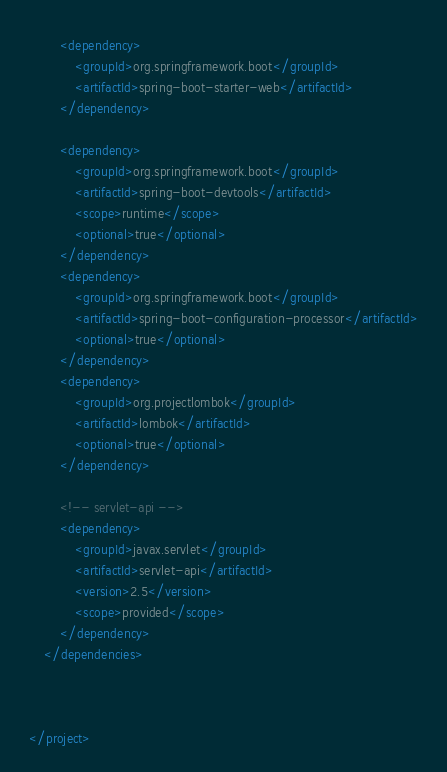<code> <loc_0><loc_0><loc_500><loc_500><_XML_>

		<dependency>
			<groupId>org.springframework.boot</groupId>
			<artifactId>spring-boot-starter-web</artifactId>
		</dependency>

		<dependency>
			<groupId>org.springframework.boot</groupId>
			<artifactId>spring-boot-devtools</artifactId>
			<scope>runtime</scope>
			<optional>true</optional>
		</dependency>
		<dependency>
			<groupId>org.springframework.boot</groupId>
			<artifactId>spring-boot-configuration-processor</artifactId>
			<optional>true</optional>
		</dependency>
		<dependency>
			<groupId>org.projectlombok</groupId>
			<artifactId>lombok</artifactId>
			<optional>true</optional>
		</dependency>

		<!-- servlet-api -->
		<dependency>
			<groupId>javax.servlet</groupId>
			<artifactId>servlet-api</artifactId>
			<version>2.5</version>
			<scope>provided</scope>
		</dependency>
	</dependencies>



</project>
</code> 